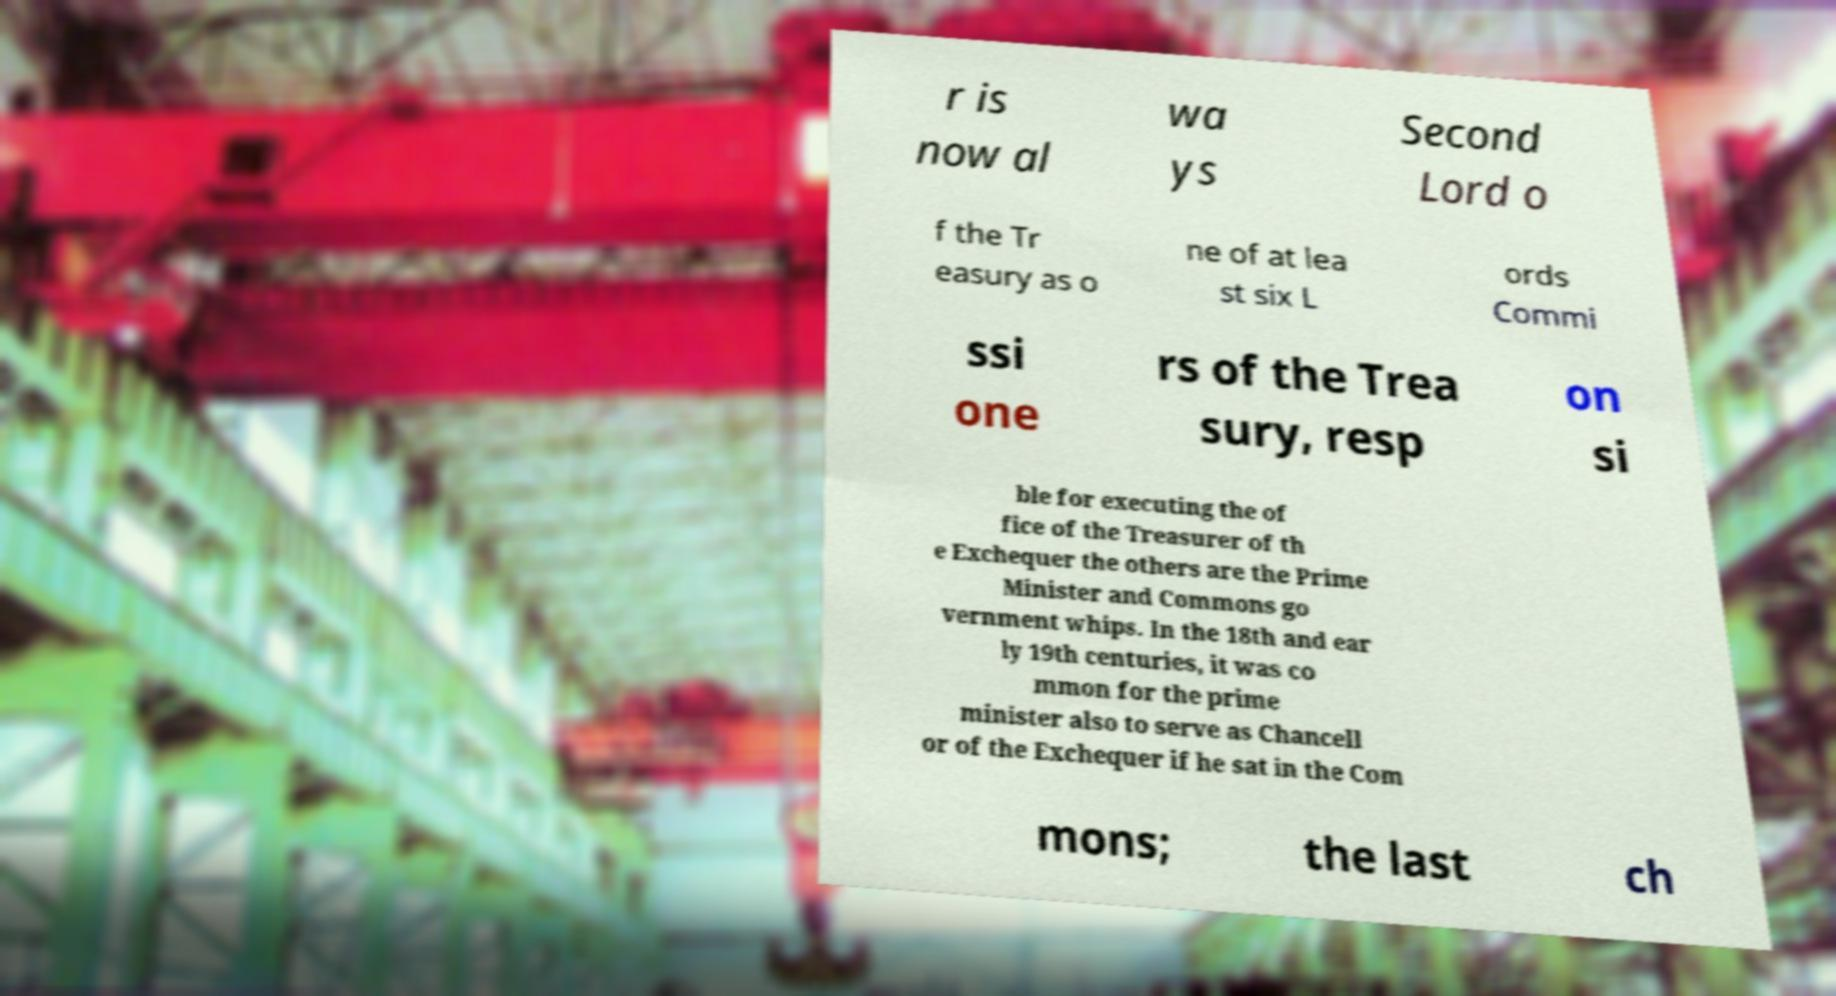For documentation purposes, I need the text within this image transcribed. Could you provide that? r is now al wa ys Second Lord o f the Tr easury as o ne of at lea st six L ords Commi ssi one rs of the Trea sury, resp on si ble for executing the of fice of the Treasurer of th e Exchequer the others are the Prime Minister and Commons go vernment whips. In the 18th and ear ly 19th centuries, it was co mmon for the prime minister also to serve as Chancell or of the Exchequer if he sat in the Com mons; the last ch 